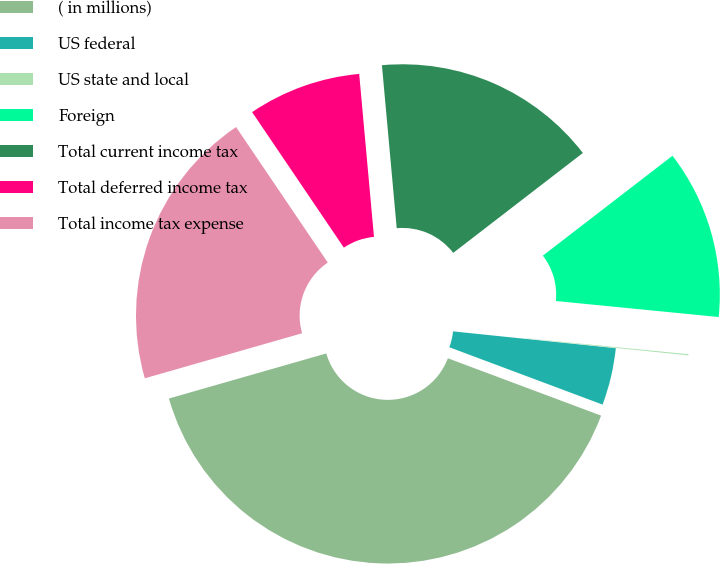Convert chart to OTSL. <chart><loc_0><loc_0><loc_500><loc_500><pie_chart><fcel>( in millions)<fcel>US federal<fcel>US state and local<fcel>Foreign<fcel>Total current income tax<fcel>Total deferred income tax<fcel>Total income tax expense<nl><fcel>39.86%<fcel>4.06%<fcel>0.08%<fcel>12.01%<fcel>15.99%<fcel>8.03%<fcel>19.97%<nl></chart> 